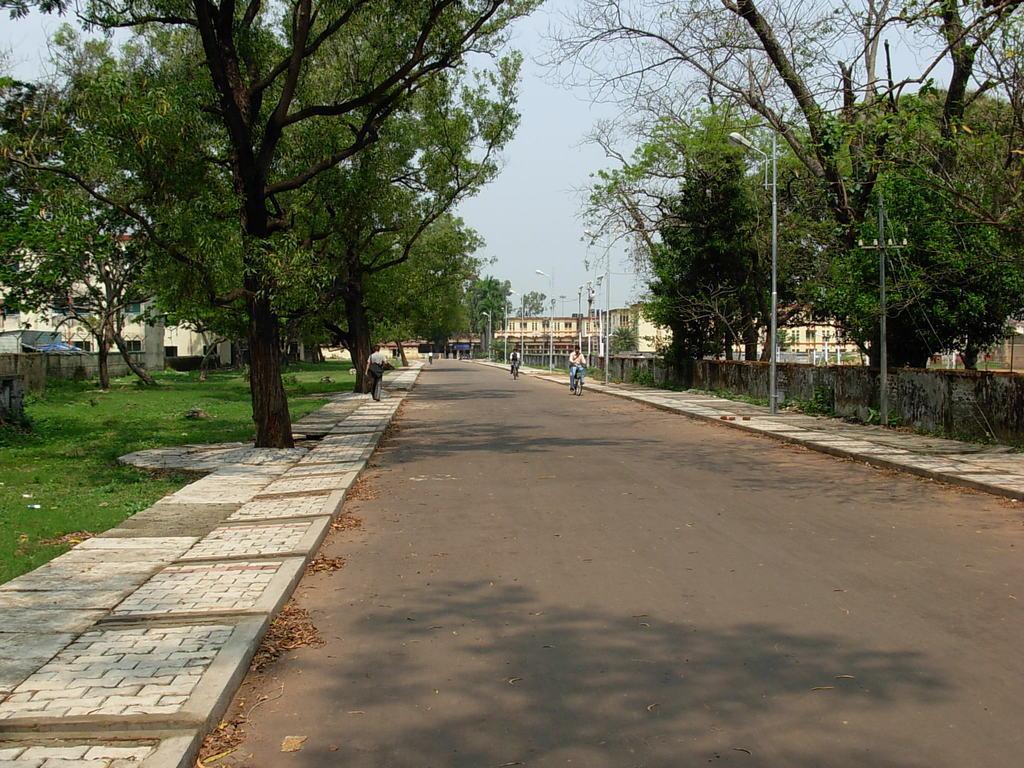In one or two sentences, can you explain what this image depicts? In the image we can see there are people, one is walking and the others are riding on the bicycle. Here we can see the road, footpath and the grass. We can even see light poles, buildings, trees and the sky. 